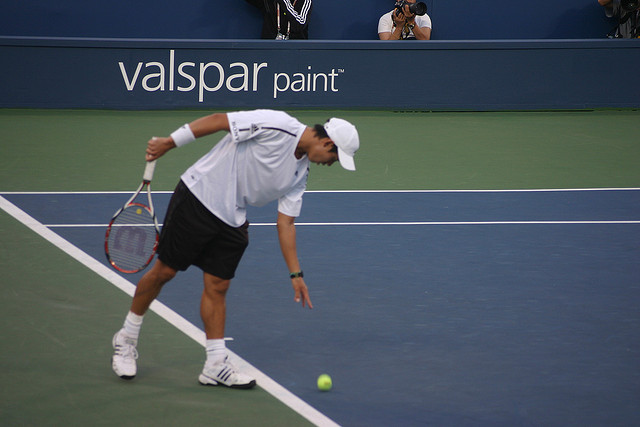Identify and read out the text in this image. valspar paint 